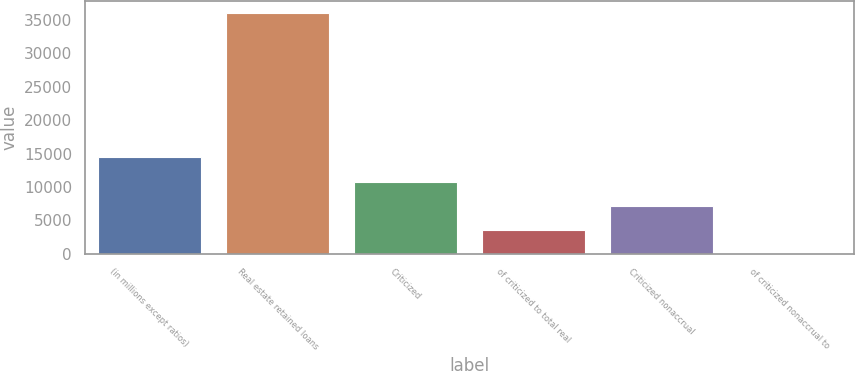Convert chart. <chart><loc_0><loc_0><loc_500><loc_500><bar_chart><fcel>(in millions except ratios)<fcel>Real estate retained loans<fcel>Criticized<fcel>of criticized to total real<fcel>Criticized nonaccrual<fcel>of criticized nonaccrual to<nl><fcel>14420.5<fcel>36051<fcel>10815.5<fcel>3605.33<fcel>7210.4<fcel>0.26<nl></chart> 